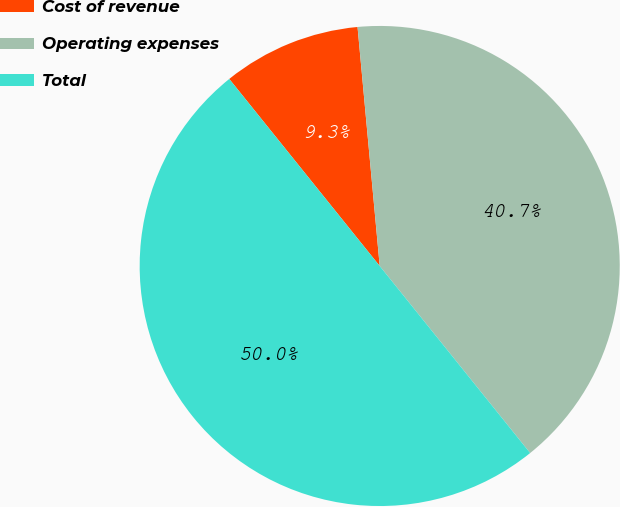<chart> <loc_0><loc_0><loc_500><loc_500><pie_chart><fcel>Cost of revenue<fcel>Operating expenses<fcel>Total<nl><fcel>9.31%<fcel>40.69%<fcel>50.0%<nl></chart> 